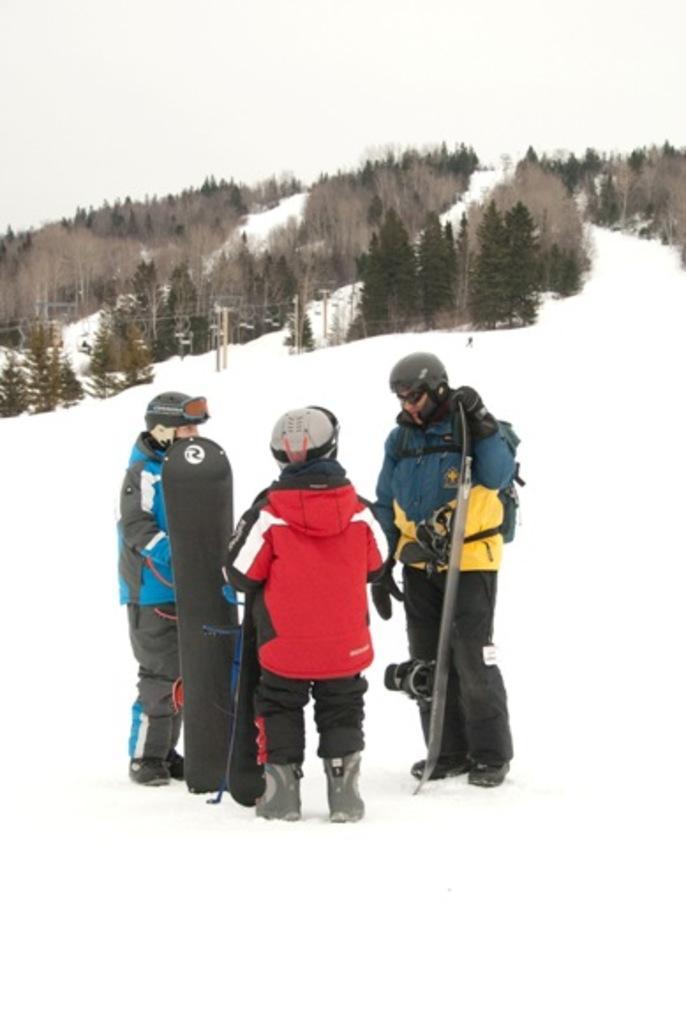Could you give a brief overview of what you see in this image? In this picture there are three persons standing. The ground is full of snow. The people are holding a snowboard, wearing helmets and boots. In the background there is sky and trees. 